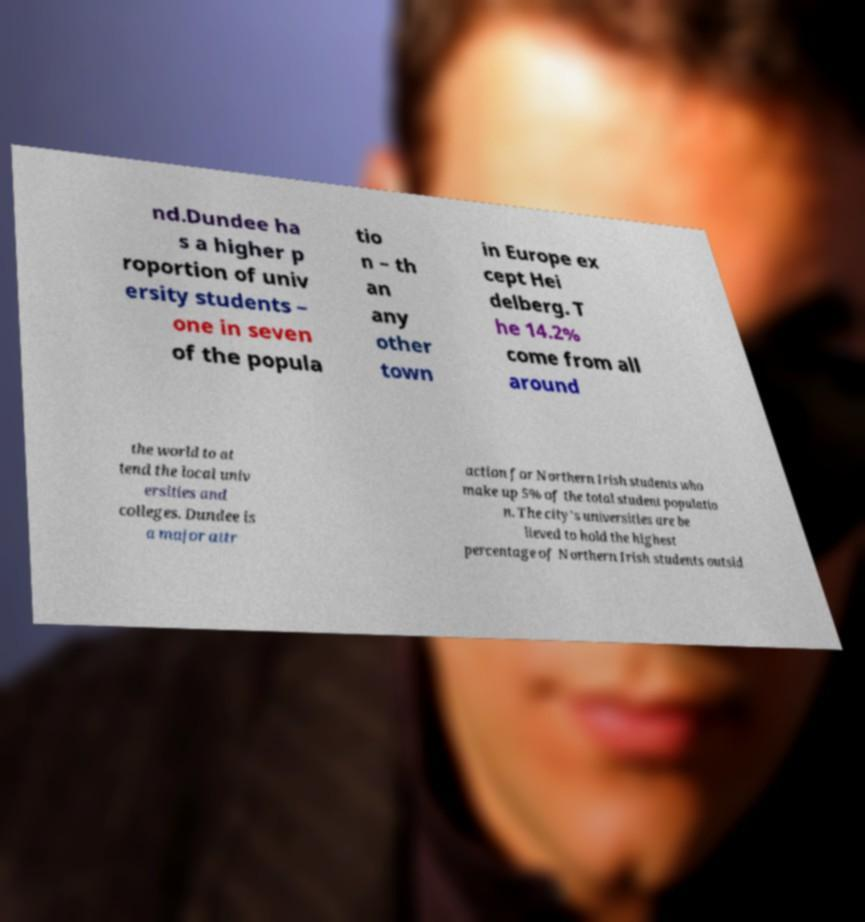Please read and relay the text visible in this image. What does it say? nd.Dundee ha s a higher p roportion of univ ersity students – one in seven of the popula tio n – th an any other town in Europe ex cept Hei delberg. T he 14.2% come from all around the world to at tend the local univ ersities and colleges. Dundee is a major attr action for Northern Irish students who make up 5% of the total student populatio n. The city's universities are be lieved to hold the highest percentage of Northern Irish students outsid 